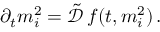Convert formula to latex. <formula><loc_0><loc_0><loc_500><loc_500>\begin{array} { r } { \partial _ { t } m _ { i } ^ { 2 } = \tilde { \mathcal { D } } \, f ( t , m _ { i } ^ { 2 } ) \, . } \end{array}</formula> 